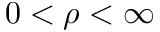<formula> <loc_0><loc_0><loc_500><loc_500>0 < \rho < \infty</formula> 